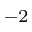Convert formula to latex. <formula><loc_0><loc_0><loc_500><loc_500>^ { - 2 }</formula> 